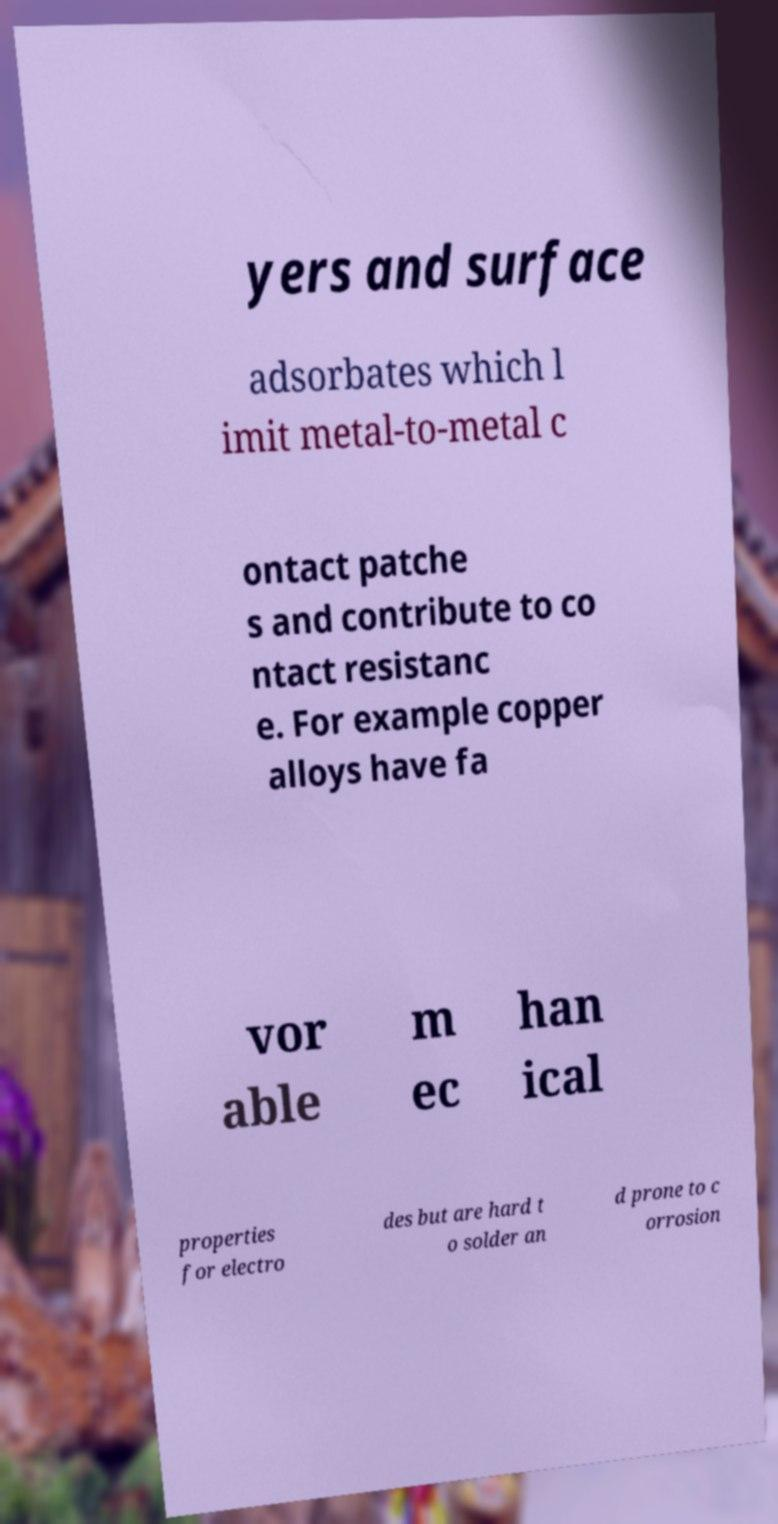For documentation purposes, I need the text within this image transcribed. Could you provide that? yers and surface adsorbates which l imit metal-to-metal c ontact patche s and contribute to co ntact resistanc e. For example copper alloys have fa vor able m ec han ical properties for electro des but are hard t o solder an d prone to c orrosion 